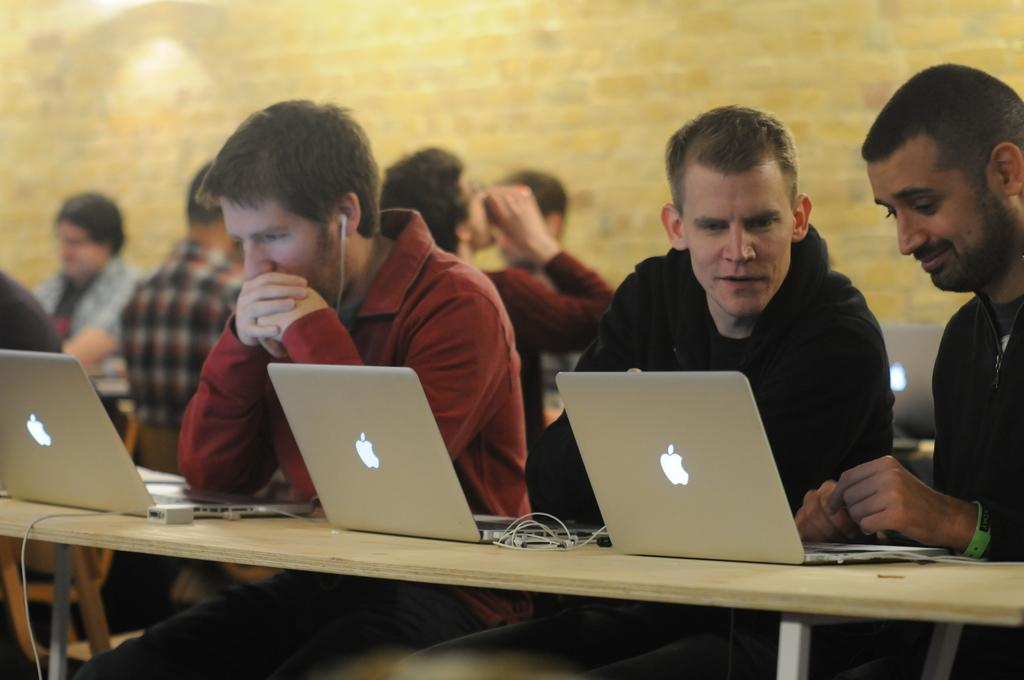How many people are in the image? There is a group of people in the image. What are the people doing in the image? The people are sitting on chairs. What is in front of the people? There is a table in front of the people. What electronic device is on the table? A laptop is present on the table. What else can be seen on the table? There are wires and chargers on the table. What is visible in the background of the image? There is a wall visible in the background of the image. How many sheep are visible in the image? There are no sheep present in the image. What type of magic is being performed by the people in the image? There is no magic being performed in the image; the people are simply sitting on chairs and using a laptop. 